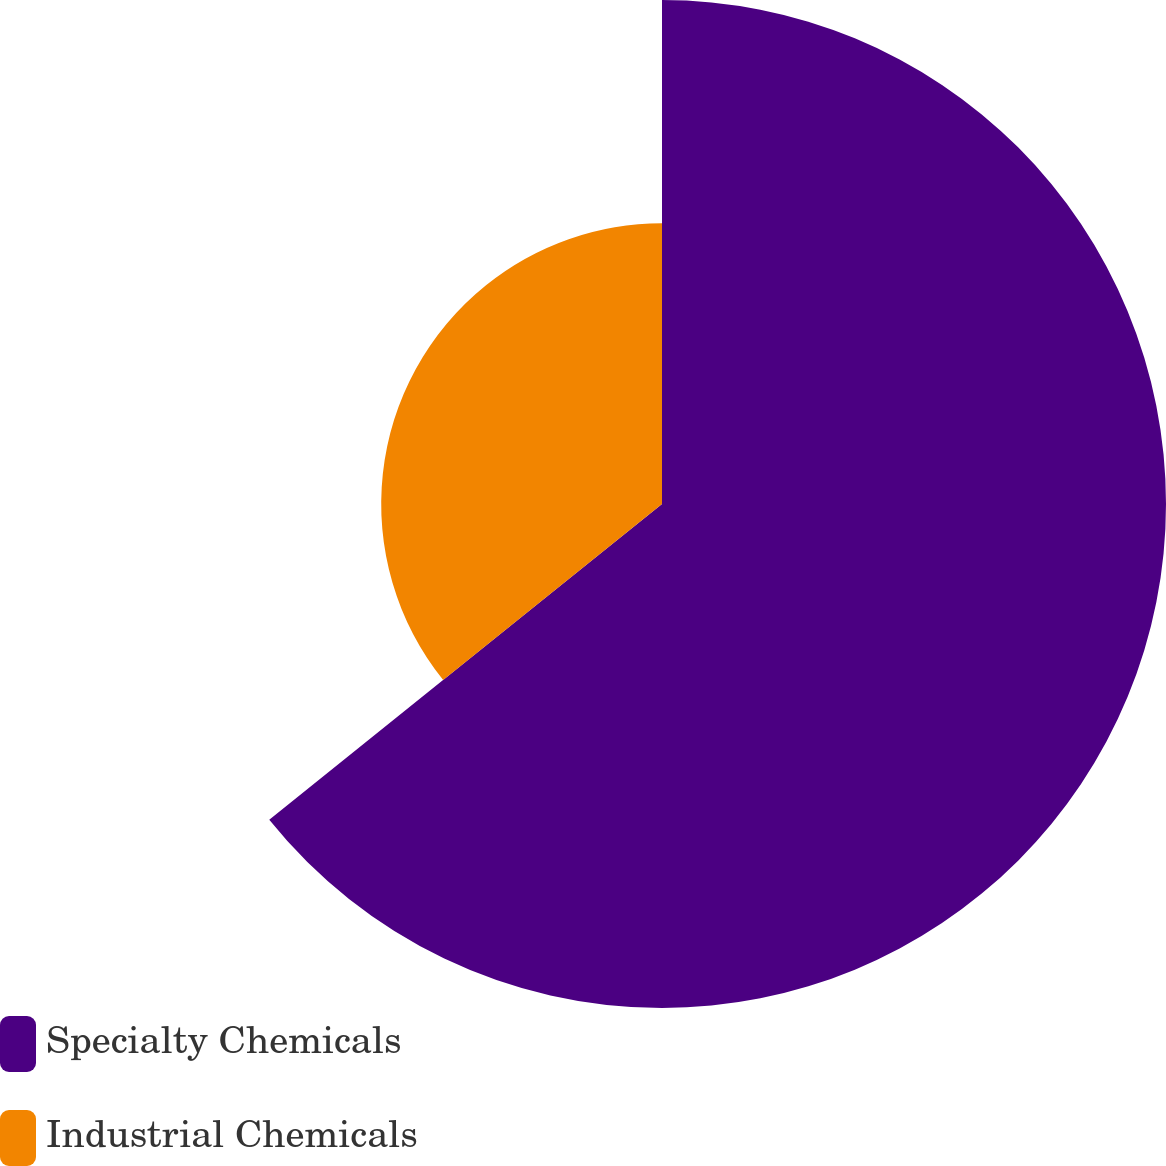Convert chart. <chart><loc_0><loc_0><loc_500><loc_500><pie_chart><fcel>Specialty Chemicals<fcel>Industrial Chemicals<nl><fcel>64.22%<fcel>35.78%<nl></chart> 